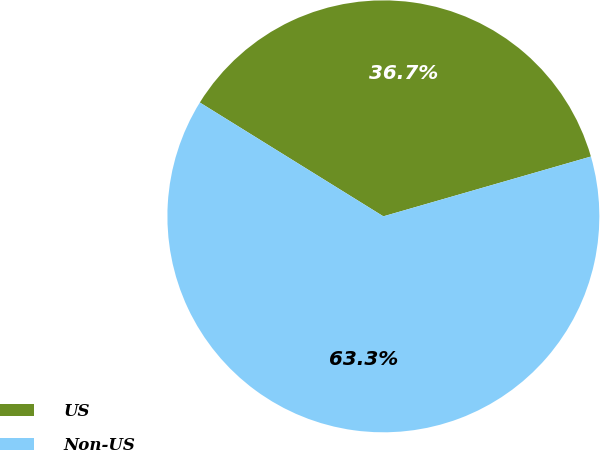Convert chart. <chart><loc_0><loc_0><loc_500><loc_500><pie_chart><fcel>US<fcel>Non-US<nl><fcel>36.7%<fcel>63.3%<nl></chart> 